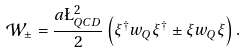<formula> <loc_0><loc_0><loc_500><loc_500>\mathcal { W } _ { \pm } = \frac { a \L _ { Q C D } ^ { 2 } } { 2 } \left ( \xi ^ { \dagger } w _ { Q } \xi ^ { \dagger } \pm \xi w _ { Q } \xi \right ) .</formula> 